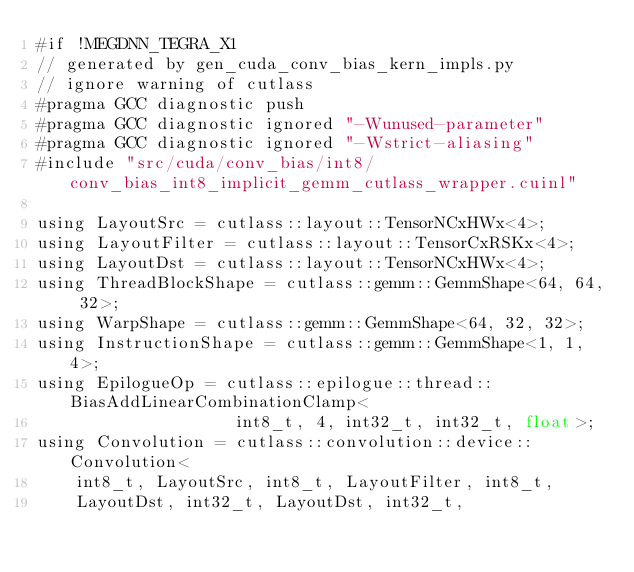Convert code to text. <code><loc_0><loc_0><loc_500><loc_500><_Cuda_>#if !MEGDNN_TEGRA_X1
// generated by gen_cuda_conv_bias_kern_impls.py
// ignore warning of cutlass
#pragma GCC diagnostic push
#pragma GCC diagnostic ignored "-Wunused-parameter"
#pragma GCC diagnostic ignored "-Wstrict-aliasing"
#include "src/cuda/conv_bias/int8/conv_bias_int8_implicit_gemm_cutlass_wrapper.cuinl"

using LayoutSrc = cutlass::layout::TensorNCxHWx<4>;
using LayoutFilter = cutlass::layout::TensorCxRSKx<4>;
using LayoutDst = cutlass::layout::TensorNCxHWx<4>;
using ThreadBlockShape = cutlass::gemm::GemmShape<64, 64, 32>;
using WarpShape = cutlass::gemm::GemmShape<64, 32, 32>;
using InstructionShape = cutlass::gemm::GemmShape<1, 1, 4>;
using EpilogueOp = cutlass::epilogue::thread::BiasAddLinearCombinationClamp<
                    int8_t, 4, int32_t, int32_t, float>;
using Convolution = cutlass::convolution::device::Convolution<
    int8_t, LayoutSrc, int8_t, LayoutFilter, int8_t, 
    LayoutDst, int32_t, LayoutDst, int32_t, </code> 